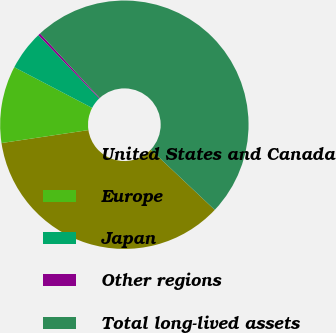Convert chart to OTSL. <chart><loc_0><loc_0><loc_500><loc_500><pie_chart><fcel>United States and Canada<fcel>Europe<fcel>Japan<fcel>Other regions<fcel>Total long-lived assets<nl><fcel>35.62%<fcel>10.02%<fcel>5.16%<fcel>0.3%<fcel>48.9%<nl></chart> 